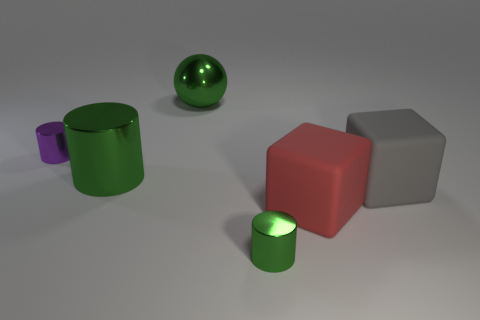What is the material of the gray object?
Make the answer very short. Rubber. Are there more green things behind the ball than red metal cubes?
Offer a terse response. No. Is there a large ball?
Offer a very short reply. Yes. How many other objects are there of the same shape as the small purple metallic thing?
Your answer should be compact. 2. Is the color of the small cylinder that is right of the big green shiny cylinder the same as the object that is behind the tiny purple shiny cylinder?
Offer a terse response. Yes. How big is the green shiny thing right of the large thing that is behind the small metal object that is behind the small green metal thing?
Ensure brevity in your answer.  Small. What shape is the thing that is in front of the gray cube and behind the small green thing?
Offer a terse response. Cube. Are there the same number of tiny purple objects that are on the right side of the large red cube and purple objects behind the purple metallic cylinder?
Make the answer very short. Yes. Is there a big green cylinder made of the same material as the gray thing?
Your answer should be compact. No. Are the big green ball that is behind the purple thing and the large red thing made of the same material?
Make the answer very short. No. 